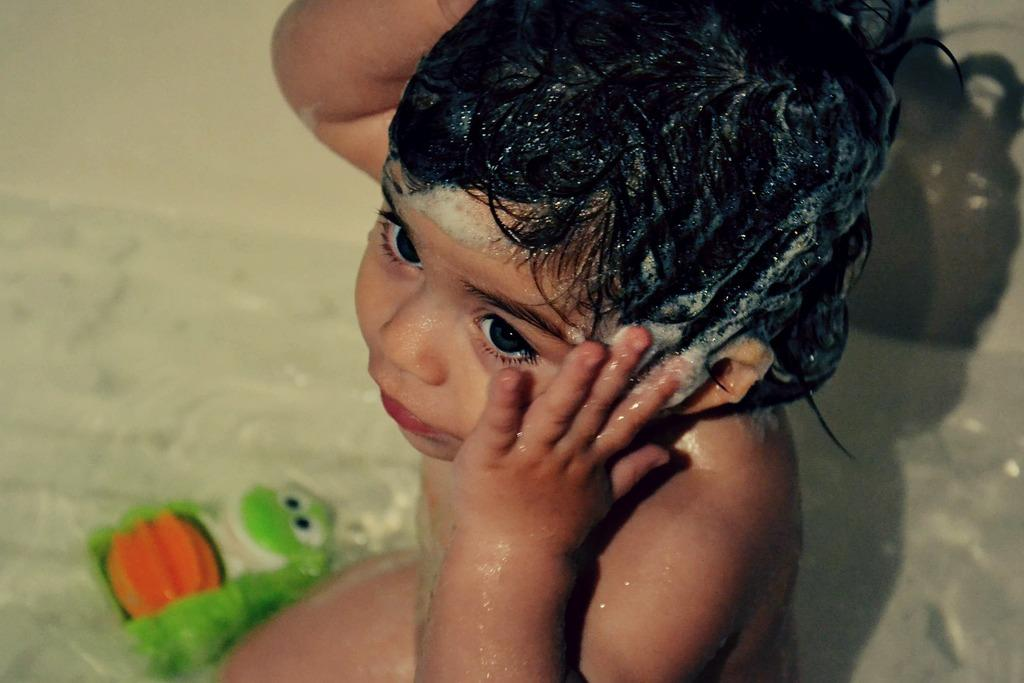What is the main subject of the image? There is a baby in the image. What is on the baby's head? The baby has foam on its head. What object is beside the baby? There is a toy beside the baby. How would you describe the background of the image? The background of the image is blurry. Can you see any flames in the image? No, there are no flames present in the image. What type of rice is being served to the baby in the image? There is no rice present in the image; the baby has foam on its head and a toy beside it. 